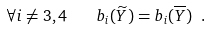<formula> <loc_0><loc_0><loc_500><loc_500>\forall i \neq 3 , 4 \quad b _ { i } ( \widetilde { Y } ) = b _ { i } ( \overline { Y } ) \ .</formula> 